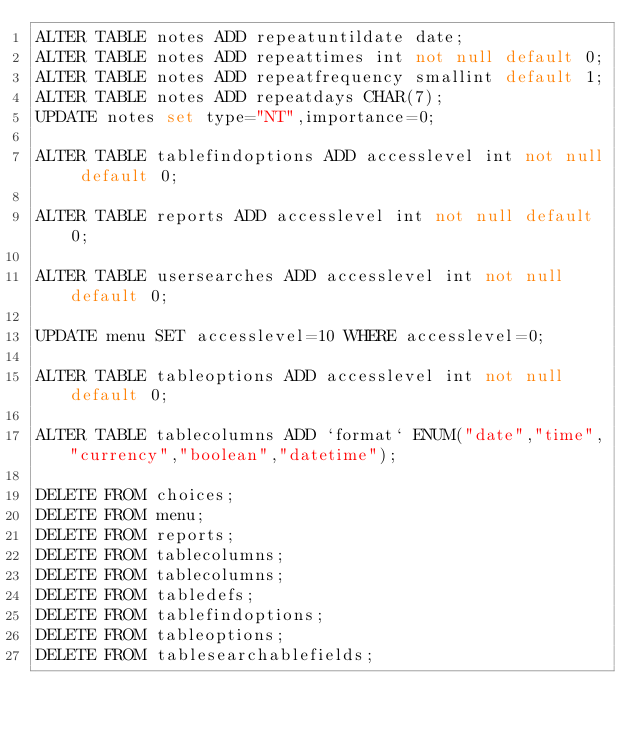Convert code to text. <code><loc_0><loc_0><loc_500><loc_500><_SQL_>ALTER TABLE notes ADD repeatuntildate date;
ALTER TABLE notes ADD repeattimes int not null default 0;
ALTER TABLE notes ADD repeatfrequency smallint default 1;
ALTER TABLE notes ADD repeatdays CHAR(7);
UPDATE notes set type="NT",importance=0;

ALTER TABLE tablefindoptions ADD accesslevel int not null default 0;

ALTER TABLE reports ADD accesslevel int not null default 0;

ALTER TABLE usersearches ADD accesslevel int not null default 0;

UPDATE menu SET accesslevel=10 WHERE accesslevel=0;

ALTER TABLE tableoptions ADD accesslevel int not null default 0;

ALTER TABLE tablecolumns ADD `format` ENUM("date","time","currency","boolean","datetime");

DELETE FROM choices;
DELETE FROM menu;
DELETE FROM reports;
DELETE FROM tablecolumns;
DELETE FROM tablecolumns;
DELETE FROM tabledefs;
DELETE FROM tablefindoptions;
DELETE FROM tableoptions;
DELETE FROM tablesearchablefields;</code> 